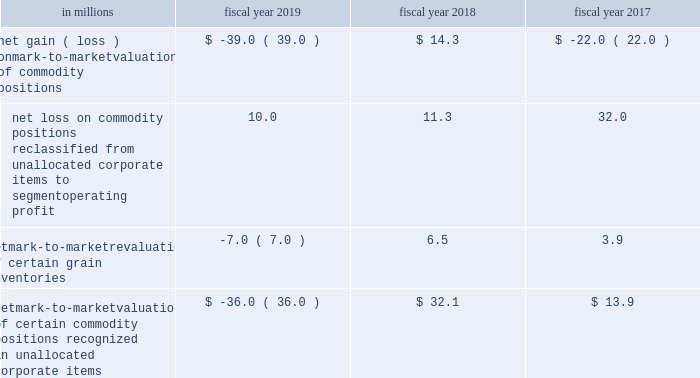Commodities purchased for use in our supply chain .
We manage our exposures through a combination of purchase orders , long-term contracts with suppliers , exchange-traded futures and options , and over-the-counter options and swaps .
We offset our exposures based on current and projected market conditions and generally seek to acquire the inputs at as close to our planned cost as possible .
We use derivatives to manage our exposure to changes in commodity prices .
We do not perform the assessments required to achieve hedge accounting for commodity derivative positions .
Accordingly , the changes in the values of these derivatives are recorded currently in cost of sales in our consolidated statements of earnings .
Although we do not meet the criteria for cash flow hedge accounting , we believe that these instruments are effective in achieving our objective of providing certainty in the future price of commodities purchased for use in our supply chain .
Accordingly , for purposes of measuring segment operating performance these gains and losses are reported in unallocated corporate items outside of segment operating results until such time that the exposure we are managing affects earnings .
At that time we reclassify the gain or loss from unallocated corporate items to segment operating profit , allowing our operating segments to realize the economic effects of the derivative without experiencing any resulting mark-to-market volatility , which remains in unallocated corporate items .
Unallocated corporate items for fiscal 2019 , 2018 and 2017 included: .
Net mark-to-market valuation of certain commodity positions recognized in unallocated corporate items $ ( 36.0 ) $ 32.1 $ 13.9 as of may 26 , 2019 , the net notional value of commodity derivatives was $ 312.5 million , of which $ 242.9 million related to agricultural inputs and $ 69.6 million related to energy inputs .
These contracts relate to inputs that generally will be utilized within the next 12 months .
Interest rate risk we are exposed to interest rate volatility with regard to future issuances of fixed-rate debt , and existing and future issuances of floating-rate debt .
Primary exposures include u.s .
Treasury rates , libor , euribor , and commercial paper rates in the united states and europe .
We use interest rate swaps , forward-starting interest rate swaps , and treasury locks to hedge our exposure to interest rate changes , to reduce the volatility of our financing costs , and to achieve a desired proportion of fixed rate versus floating-rate debt , based on current and projected market conditions .
Generally under these swaps , we agree with a counterparty to exchange the difference between fixed-rate and floating-rate interest amounts based on an agreed upon notional principal amount .
Floating interest rate exposures 2014 floating-to-fixed interest rate swaps are accounted for as cash flow hedges , as are all hedges of forecasted issuances of debt .
Effectiveness is assessed based on either the perfectly effective hypothetical derivative method or changes in the present value of interest payments on the underlying debt .
Effective gains and losses deferred to aoci are reclassified into earnings over the life of the associated debt .
Ineffective gains and losses are recorded as net interest .
The amount of hedge ineffectiveness was less than $ 1 million in fiscal 2019 , a $ 2.6 million loss in fiscal 2018 , and less than $ 1 million in fiscal 2017 .
Fixed interest rate exposures 2014 fixed-to-floating interest rate swaps are accounted for as fair value hedges with effectiveness assessed based on changes in the fair value of the underlying debt and derivatives , using .
What was the average net loss on commodity positions reclassified from unallocated corporate items to segment operating profit from 2017 to 2019? 
Computations: ((32.0 + (10.0 + 11.3)) / 3)
Answer: 17.76667. 